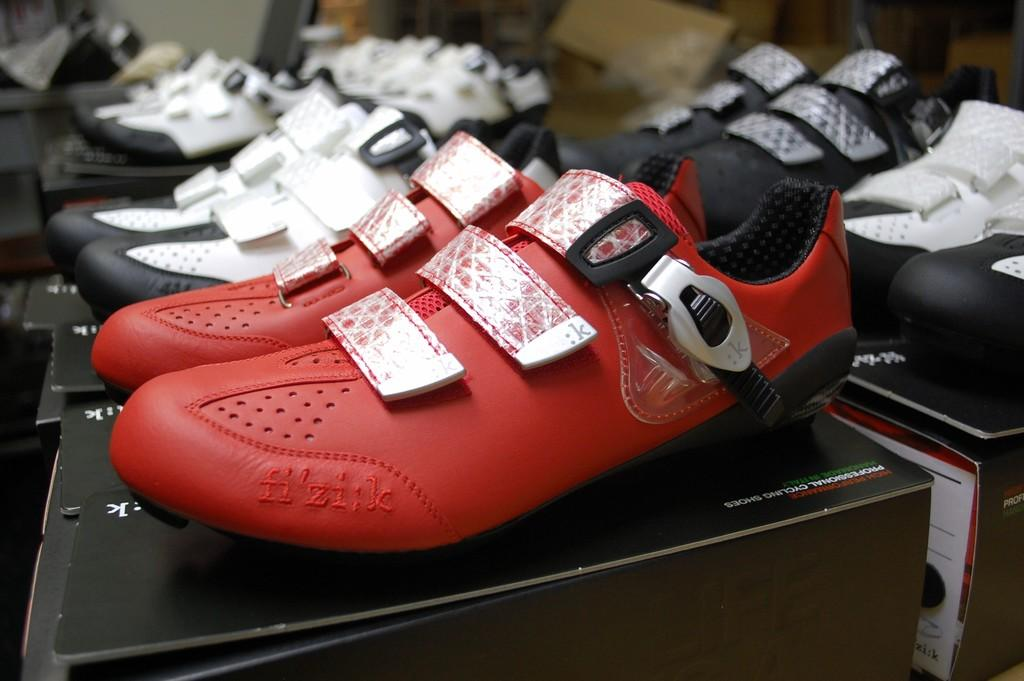What type of items can be seen in the image? There are pairs of shoes in the image. How are the shoes arranged or displayed? The shoes are on boxes. What color are the shoes? The shoes are red in color. What language is spoken by the shoes in the image? The shoes do not speak a language, as they are inanimate objects. 